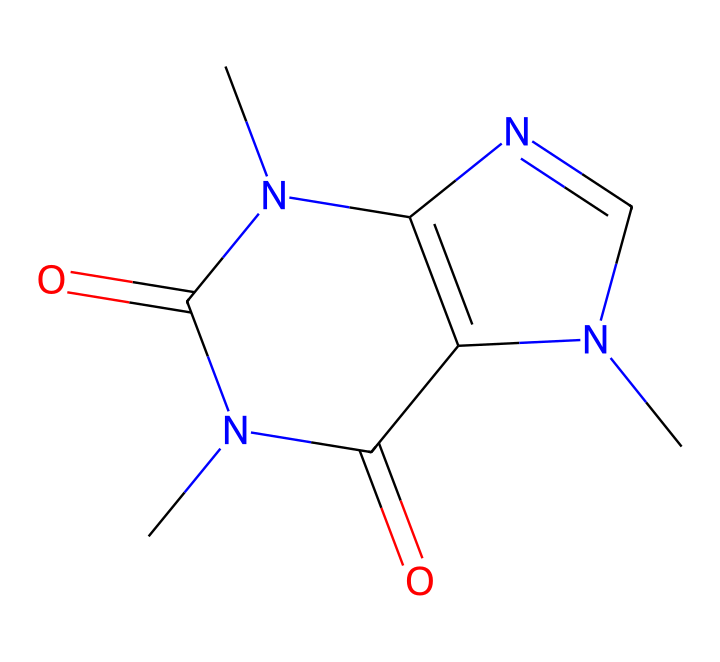What is the name of this chemical? The given SMILES represents caffeine, which is identified by its specific arrangement of carbon, nitrogen, and oxygen atoms as encapsulated in the SMILES notation.
Answer: caffeine How many nitrogen atoms are there? By analyzing the SMILES structure, there are three nitrogen atoms present in the arrangement, identifiable by the 'N' symbols.
Answer: three What is the number of carbon atoms? In the SMILES string, counting the 'C' letters indicates there are eight carbon atoms present in the structure of caffeine.
Answer: eight Which functional groups are present in this structure? The structure contains carbonyl groups (as indicated by the 'C=O' portions) and is characterized as an amide due to the presence of nitrogen next to carbonyls, typical for alkaloids.
Answer: amide, carbonyl What is the primary functional role of caffeine in global trade and negotiations? Caffeine primarily acts as a stimulant, which can enhance focus and cognitive ability, potentially impacting decision-making processes during diplomatic negotiations and trade discussions.
Answer: stimulant How do the structural features of caffeine contribute to its psychoactive effects? The nitrogen atoms serve as bases, allowing caffeine to interact with adenosine receptors in the brain, leading to increased alertness and reduced fatigue, which can influence geopolitical discussions.
Answer: interacts with receptors What characteristic makes caffeine an alkaloid? Caffeine is categorized as an alkaloid due to the presence of nitrogen atoms within a heterocyclic structure, which is a hallmark feature of many alkaloids, contributing to its physiological effects.
Answer: nitrogen bearing structure 